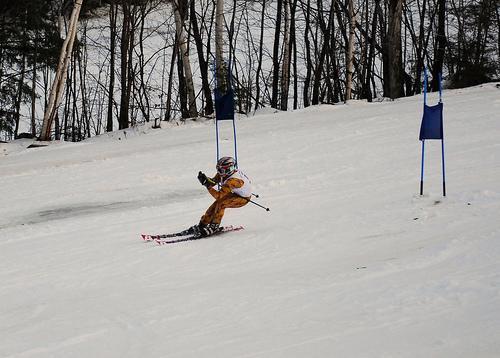How many skiers are pictured?
Give a very brief answer. 1. How many people are in the scene?
Give a very brief answer. 1. How many chairs around the table?
Give a very brief answer. 0. 